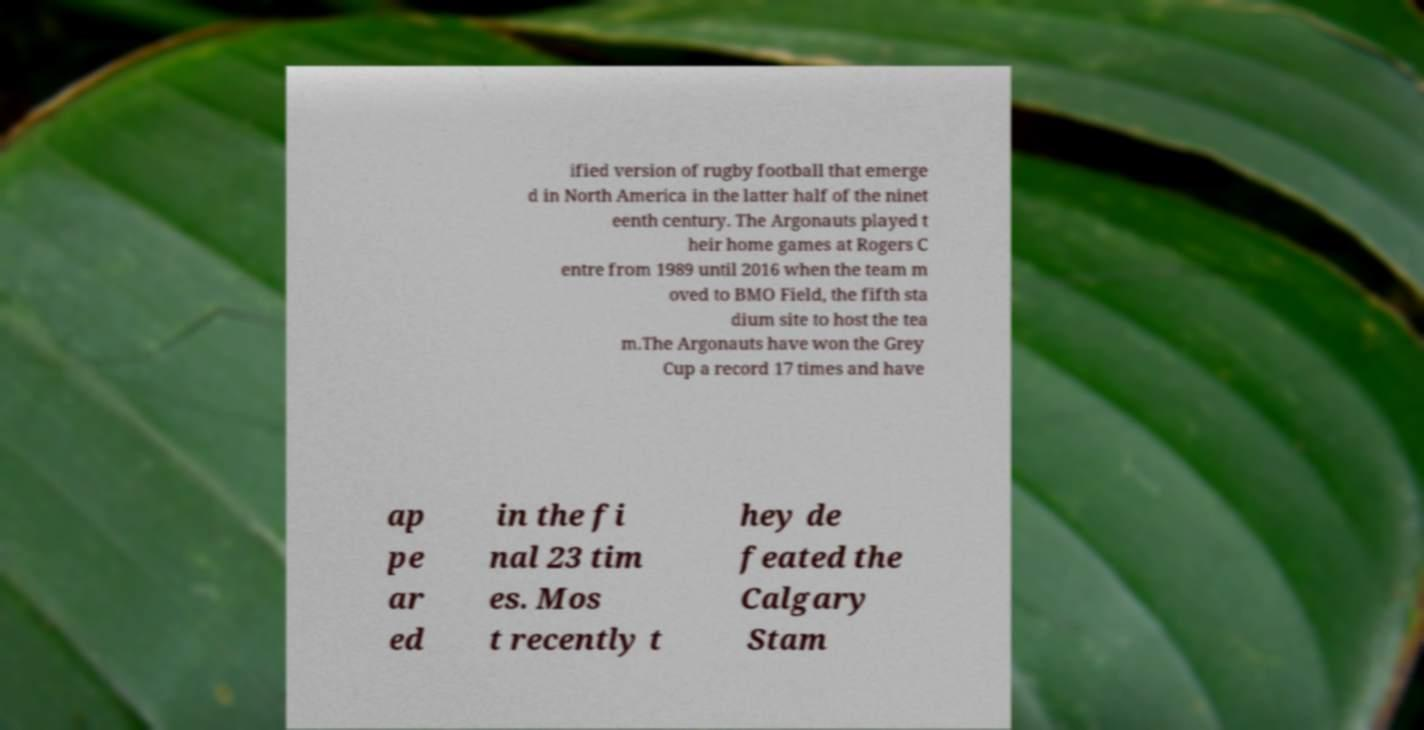Could you extract and type out the text from this image? ified version of rugby football that emerge d in North America in the latter half of the ninet eenth century. The Argonauts played t heir home games at Rogers C entre from 1989 until 2016 when the team m oved to BMO Field, the fifth sta dium site to host the tea m.The Argonauts have won the Grey Cup a record 17 times and have ap pe ar ed in the fi nal 23 tim es. Mos t recently t hey de feated the Calgary Stam 